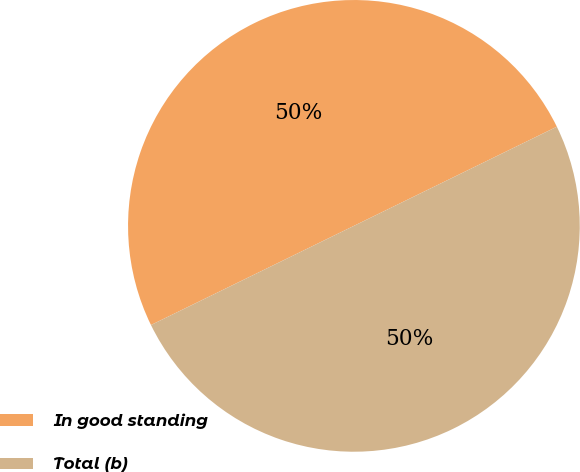Convert chart. <chart><loc_0><loc_0><loc_500><loc_500><pie_chart><fcel>In good standing<fcel>Total (b)<nl><fcel>50.0%<fcel>50.0%<nl></chart> 